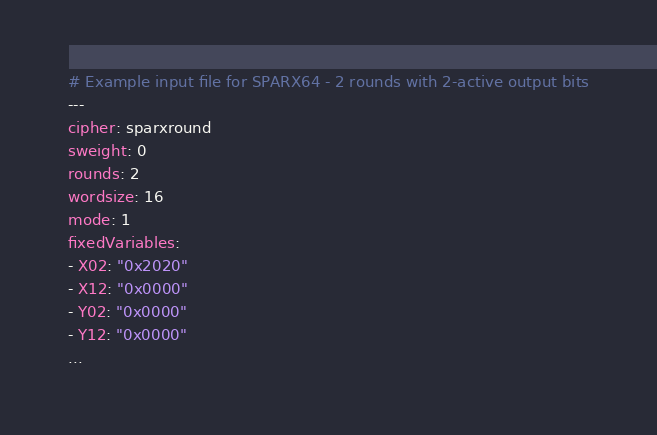Convert code to text. <code><loc_0><loc_0><loc_500><loc_500><_YAML_># Example input file for SPARX64 - 2 rounds with 2-active output bits
---
cipher: sparxround
sweight: 0
rounds: 2
wordsize: 16
mode: 1
fixedVariables:
- X02: "0x2020"
- X12: "0x0000"
- Y02: "0x0000"
- Y12: "0x0000"
...

</code> 